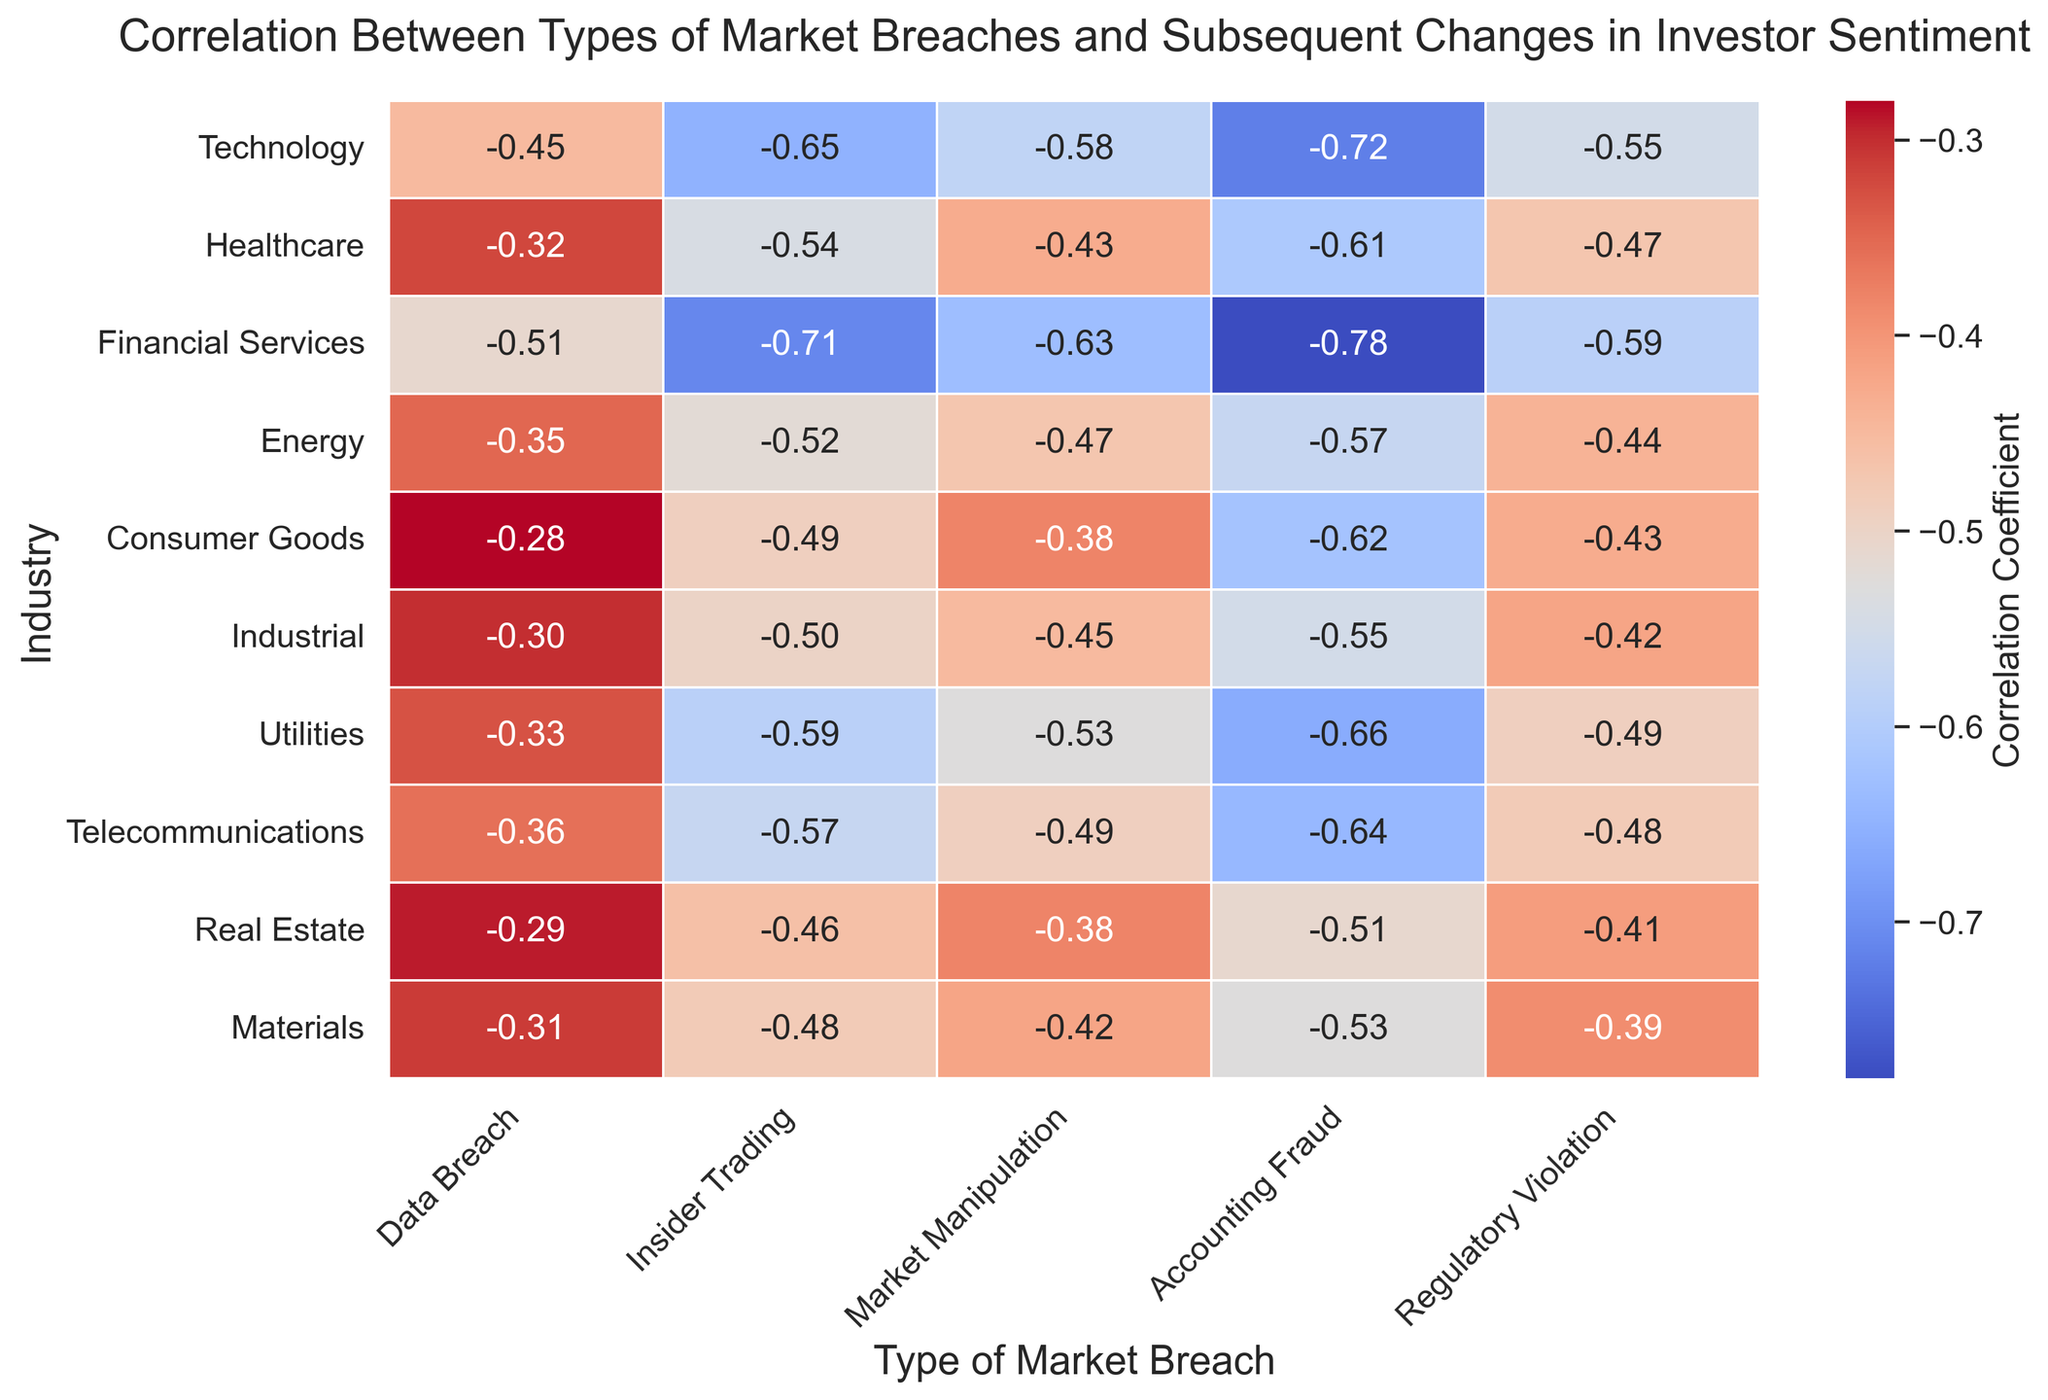Which type of market breach has the highest negative correlation with investor sentiment in the Financial Services industry? The Financial Services industry row shows the correlation coefficients for each market breach type. The most negative value indicates the highest negative correlation. In the Financial Services industry, the Accounting Fraud column has the value -0.78, which is the most negative.
Answer: Accounting Fraud In which industry does insider trading have the least negative impact on investor sentiment? The Insider Trading column lists the correlation coefficients for different industries. The least negative value (closest to zero) indicates the least negative impact. The Consumer Goods industry has the value -0.49, which is the least negative in this column.
Answer: Consumer Goods Across all industries, which type of market breach generally maintains the most consistently severe negative correlation with investor sentiment? To identify consistency in severe negative correlations, we need to check the columns for similar negative values across industries. Accounting Fraud shows consistently highly negative correlations like -0.72, -0.61, -0.78, -0.57, etc., indicating it generally maintains severe negative impacts.
Answer: Accounting Fraud How does the correlation coefficient between data breaches and investor sentiment in the Technology industry compare to that in the Energy industry? The Data Breach column has the correlation coefficients: Technology (-0.45) and Energy (-0.35). The value in Technology is more negative than in Energy, indicating a larger negative impact in the Technology industry.
Answer: The correlation is more negative in the Technology industry Which industry shows the greatest disparity between the impacts of accounting fraud and data breaches on investor sentiment? The disparity can be measured by the difference between the correlation coefficients of Accounting Fraud and Data Breach within each industry. The greatest difference observed is in the Financial Services industry: -0.78 (Accounting Fraud) and -0.51 (Data Breach).
Answer: Financial Services What is the average negative correlation between market manipulation and investor sentiment across all industries? To find the average, sum the correlation values in the Market Manipulation column: -0.58, -0.43, -0.63, -0.47, -0.38, -0.45, -0.53, -0.49, -0.38, -0.42, then divide by the number of industries (10). So, the calculation is: (-0.58 - 0.43 - 0.63 - 0.47 - 0.38 - 0.45 - 0.53 - 0.49 - 0.38 - 0.42) / 10 = -4.76 / 10 = -0.476.
Answer: -0.48 Which type of market breach shows the least variation in its impact on investor sentiment across different industries? Variation is measured by the range (highest minus lowest value) in each column. Calculate the range for each type: Data Breach (0.23), Insider Trading (0.25), Market Manipulation (0.25), Accounting Fraud (0.27), Regulatory Violation (0.20). Regulatory Violation shows the least variation, with a range of 0.20.
Answer: Regulatory Violation 